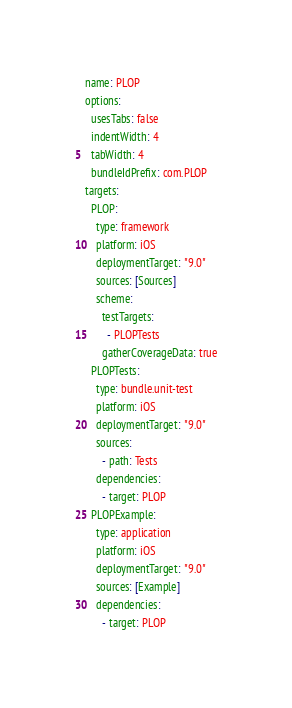Convert code to text. <code><loc_0><loc_0><loc_500><loc_500><_YAML_>name: PLOP
options:
  usesTabs: false
  indentWidth: 4
  tabWidth: 4
  bundleIdPrefix: com.PLOP
targets:
  PLOP:
    type: framework
    platform: iOS
    deploymentTarget: "9.0"
    sources: [Sources]
    scheme:
      testTargets:
        - PLOPTests
      gatherCoverageData: true
  PLOPTests:
    type: bundle.unit-test
    platform: iOS
    deploymentTarget: "9.0"
    sources:
      - path: Tests
    dependencies:
      - target: PLOP
  PLOPExample:
    type: application
    platform: iOS
    deploymentTarget: "9.0"
    sources: [Example]
    dependencies:
      - target: PLOP

</code> 